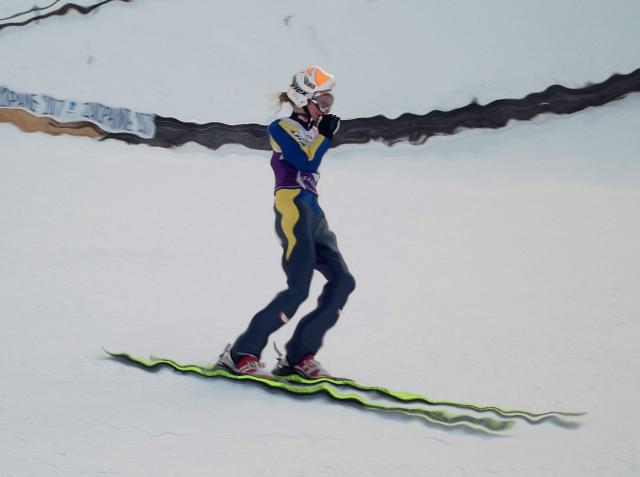What kind of activity is being performed in the image? The person in the image is engaged in a snow sport, specifically snowboarding. The individual is captured mid-action, suggesting they are likely navigating a slope or performing a trick. 